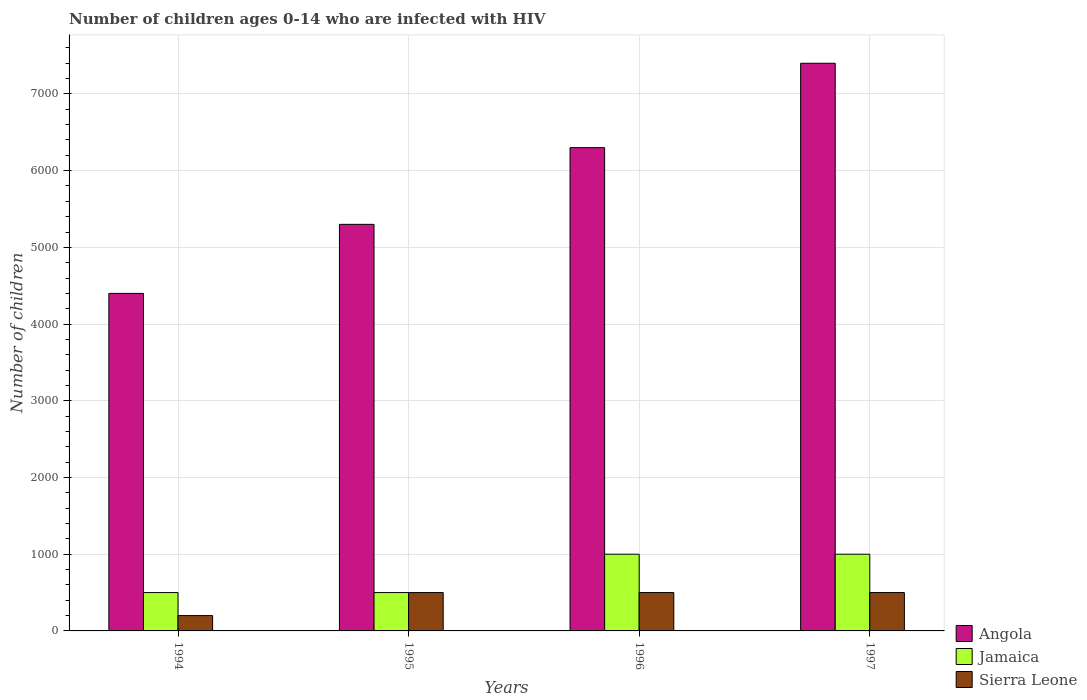How many different coloured bars are there?
Ensure brevity in your answer.  3. How many groups of bars are there?
Ensure brevity in your answer.  4. Are the number of bars per tick equal to the number of legend labels?
Keep it short and to the point. Yes. How many bars are there on the 1st tick from the left?
Offer a terse response. 3. What is the label of the 3rd group of bars from the left?
Provide a short and direct response. 1996. What is the number of HIV infected children in Sierra Leone in 1994?
Provide a succinct answer. 200. Across all years, what is the maximum number of HIV infected children in Angola?
Make the answer very short. 7400. Across all years, what is the minimum number of HIV infected children in Jamaica?
Make the answer very short. 500. What is the total number of HIV infected children in Jamaica in the graph?
Offer a terse response. 3000. What is the difference between the number of HIV infected children in Angola in 1996 and that in 1997?
Offer a terse response. -1100. What is the difference between the number of HIV infected children in Jamaica in 1996 and the number of HIV infected children in Sierra Leone in 1994?
Make the answer very short. 800. What is the average number of HIV infected children in Sierra Leone per year?
Your answer should be compact. 425. In the year 1997, what is the difference between the number of HIV infected children in Angola and number of HIV infected children in Sierra Leone?
Offer a terse response. 6900. What is the ratio of the number of HIV infected children in Angola in 1995 to that in 1996?
Provide a succinct answer. 0.84. What is the difference between the highest and the second highest number of HIV infected children in Angola?
Your answer should be compact. 1100. What is the difference between the highest and the lowest number of HIV infected children in Sierra Leone?
Your response must be concise. 300. In how many years, is the number of HIV infected children in Sierra Leone greater than the average number of HIV infected children in Sierra Leone taken over all years?
Give a very brief answer. 3. What does the 1st bar from the left in 1995 represents?
Provide a succinct answer. Angola. What does the 2nd bar from the right in 1996 represents?
Make the answer very short. Jamaica. Is it the case that in every year, the sum of the number of HIV infected children in Sierra Leone and number of HIV infected children in Angola is greater than the number of HIV infected children in Jamaica?
Your response must be concise. Yes. How many years are there in the graph?
Provide a succinct answer. 4. Does the graph contain any zero values?
Your answer should be very brief. No. Where does the legend appear in the graph?
Your answer should be very brief. Bottom right. How are the legend labels stacked?
Give a very brief answer. Vertical. What is the title of the graph?
Offer a very short reply. Number of children ages 0-14 who are infected with HIV. Does "Nepal" appear as one of the legend labels in the graph?
Your answer should be very brief. No. What is the label or title of the X-axis?
Offer a terse response. Years. What is the label or title of the Y-axis?
Your answer should be very brief. Number of children. What is the Number of children of Angola in 1994?
Offer a terse response. 4400. What is the Number of children in Sierra Leone in 1994?
Give a very brief answer. 200. What is the Number of children in Angola in 1995?
Provide a succinct answer. 5300. What is the Number of children of Jamaica in 1995?
Your answer should be very brief. 500. What is the Number of children in Angola in 1996?
Your answer should be compact. 6300. What is the Number of children in Sierra Leone in 1996?
Your response must be concise. 500. What is the Number of children of Angola in 1997?
Keep it short and to the point. 7400. What is the Number of children in Jamaica in 1997?
Your answer should be compact. 1000. What is the Number of children in Sierra Leone in 1997?
Your answer should be compact. 500. Across all years, what is the maximum Number of children in Angola?
Your response must be concise. 7400. Across all years, what is the minimum Number of children of Angola?
Your answer should be very brief. 4400. What is the total Number of children in Angola in the graph?
Provide a short and direct response. 2.34e+04. What is the total Number of children in Jamaica in the graph?
Offer a terse response. 3000. What is the total Number of children in Sierra Leone in the graph?
Provide a succinct answer. 1700. What is the difference between the Number of children of Angola in 1994 and that in 1995?
Your response must be concise. -900. What is the difference between the Number of children in Sierra Leone in 1994 and that in 1995?
Offer a very short reply. -300. What is the difference between the Number of children of Angola in 1994 and that in 1996?
Keep it short and to the point. -1900. What is the difference between the Number of children of Jamaica in 1994 and that in 1996?
Give a very brief answer. -500. What is the difference between the Number of children in Sierra Leone in 1994 and that in 1996?
Your answer should be compact. -300. What is the difference between the Number of children in Angola in 1994 and that in 1997?
Offer a very short reply. -3000. What is the difference between the Number of children in Jamaica in 1994 and that in 1997?
Your response must be concise. -500. What is the difference between the Number of children in Sierra Leone in 1994 and that in 1997?
Keep it short and to the point. -300. What is the difference between the Number of children of Angola in 1995 and that in 1996?
Keep it short and to the point. -1000. What is the difference between the Number of children of Jamaica in 1995 and that in 1996?
Your answer should be very brief. -500. What is the difference between the Number of children in Sierra Leone in 1995 and that in 1996?
Make the answer very short. 0. What is the difference between the Number of children of Angola in 1995 and that in 1997?
Offer a very short reply. -2100. What is the difference between the Number of children in Jamaica in 1995 and that in 1997?
Your answer should be compact. -500. What is the difference between the Number of children in Sierra Leone in 1995 and that in 1997?
Your answer should be very brief. 0. What is the difference between the Number of children in Angola in 1996 and that in 1997?
Keep it short and to the point. -1100. What is the difference between the Number of children in Angola in 1994 and the Number of children in Jamaica in 1995?
Keep it short and to the point. 3900. What is the difference between the Number of children of Angola in 1994 and the Number of children of Sierra Leone in 1995?
Your answer should be very brief. 3900. What is the difference between the Number of children in Jamaica in 1994 and the Number of children in Sierra Leone in 1995?
Your response must be concise. 0. What is the difference between the Number of children in Angola in 1994 and the Number of children in Jamaica in 1996?
Keep it short and to the point. 3400. What is the difference between the Number of children in Angola in 1994 and the Number of children in Sierra Leone in 1996?
Offer a terse response. 3900. What is the difference between the Number of children in Angola in 1994 and the Number of children in Jamaica in 1997?
Provide a succinct answer. 3400. What is the difference between the Number of children of Angola in 1994 and the Number of children of Sierra Leone in 1997?
Keep it short and to the point. 3900. What is the difference between the Number of children in Jamaica in 1994 and the Number of children in Sierra Leone in 1997?
Offer a terse response. 0. What is the difference between the Number of children in Angola in 1995 and the Number of children in Jamaica in 1996?
Make the answer very short. 4300. What is the difference between the Number of children of Angola in 1995 and the Number of children of Sierra Leone in 1996?
Your answer should be compact. 4800. What is the difference between the Number of children of Jamaica in 1995 and the Number of children of Sierra Leone in 1996?
Provide a short and direct response. 0. What is the difference between the Number of children in Angola in 1995 and the Number of children in Jamaica in 1997?
Provide a succinct answer. 4300. What is the difference between the Number of children of Angola in 1995 and the Number of children of Sierra Leone in 1997?
Your answer should be compact. 4800. What is the difference between the Number of children of Angola in 1996 and the Number of children of Jamaica in 1997?
Give a very brief answer. 5300. What is the difference between the Number of children of Angola in 1996 and the Number of children of Sierra Leone in 1997?
Provide a short and direct response. 5800. What is the difference between the Number of children of Jamaica in 1996 and the Number of children of Sierra Leone in 1997?
Keep it short and to the point. 500. What is the average Number of children in Angola per year?
Your answer should be very brief. 5850. What is the average Number of children in Jamaica per year?
Your answer should be very brief. 750. What is the average Number of children of Sierra Leone per year?
Your answer should be very brief. 425. In the year 1994, what is the difference between the Number of children in Angola and Number of children in Jamaica?
Offer a very short reply. 3900. In the year 1994, what is the difference between the Number of children in Angola and Number of children in Sierra Leone?
Provide a short and direct response. 4200. In the year 1994, what is the difference between the Number of children in Jamaica and Number of children in Sierra Leone?
Ensure brevity in your answer.  300. In the year 1995, what is the difference between the Number of children in Angola and Number of children in Jamaica?
Give a very brief answer. 4800. In the year 1995, what is the difference between the Number of children in Angola and Number of children in Sierra Leone?
Your response must be concise. 4800. In the year 1996, what is the difference between the Number of children of Angola and Number of children of Jamaica?
Give a very brief answer. 5300. In the year 1996, what is the difference between the Number of children in Angola and Number of children in Sierra Leone?
Keep it short and to the point. 5800. In the year 1996, what is the difference between the Number of children in Jamaica and Number of children in Sierra Leone?
Offer a terse response. 500. In the year 1997, what is the difference between the Number of children in Angola and Number of children in Jamaica?
Make the answer very short. 6400. In the year 1997, what is the difference between the Number of children of Angola and Number of children of Sierra Leone?
Make the answer very short. 6900. What is the ratio of the Number of children of Angola in 1994 to that in 1995?
Make the answer very short. 0.83. What is the ratio of the Number of children of Jamaica in 1994 to that in 1995?
Your answer should be very brief. 1. What is the ratio of the Number of children of Angola in 1994 to that in 1996?
Provide a succinct answer. 0.7. What is the ratio of the Number of children of Sierra Leone in 1994 to that in 1996?
Your response must be concise. 0.4. What is the ratio of the Number of children of Angola in 1994 to that in 1997?
Make the answer very short. 0.59. What is the ratio of the Number of children in Jamaica in 1994 to that in 1997?
Offer a terse response. 0.5. What is the ratio of the Number of children of Angola in 1995 to that in 1996?
Keep it short and to the point. 0.84. What is the ratio of the Number of children of Sierra Leone in 1995 to that in 1996?
Offer a terse response. 1. What is the ratio of the Number of children of Angola in 1995 to that in 1997?
Offer a very short reply. 0.72. What is the ratio of the Number of children of Jamaica in 1995 to that in 1997?
Provide a succinct answer. 0.5. What is the ratio of the Number of children in Angola in 1996 to that in 1997?
Provide a succinct answer. 0.85. What is the ratio of the Number of children in Jamaica in 1996 to that in 1997?
Your answer should be compact. 1. What is the difference between the highest and the second highest Number of children in Angola?
Your answer should be very brief. 1100. What is the difference between the highest and the second highest Number of children of Jamaica?
Give a very brief answer. 0. What is the difference between the highest and the lowest Number of children of Angola?
Your response must be concise. 3000. What is the difference between the highest and the lowest Number of children in Jamaica?
Offer a terse response. 500. What is the difference between the highest and the lowest Number of children of Sierra Leone?
Keep it short and to the point. 300. 